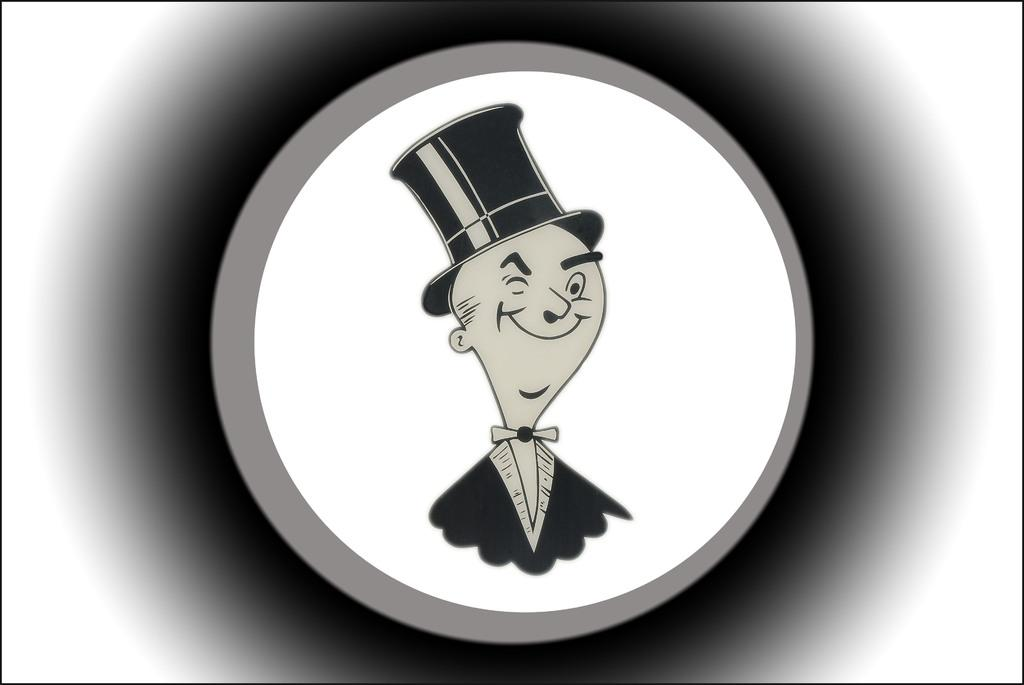What type of media is the image? The image is an animation. What colors are used in the animation? The colors in the image are white, black, and ash. Can you describe the person in the animation? There is a person in the image, and they are wearing a black-colored dress and a black-colored hat. What expression does the person have? The person is smiling in the animation. What is the name of the rabbit in the animation? There is no rabbit present in the animation; it features a person wearing a black-colored dress and hat. 